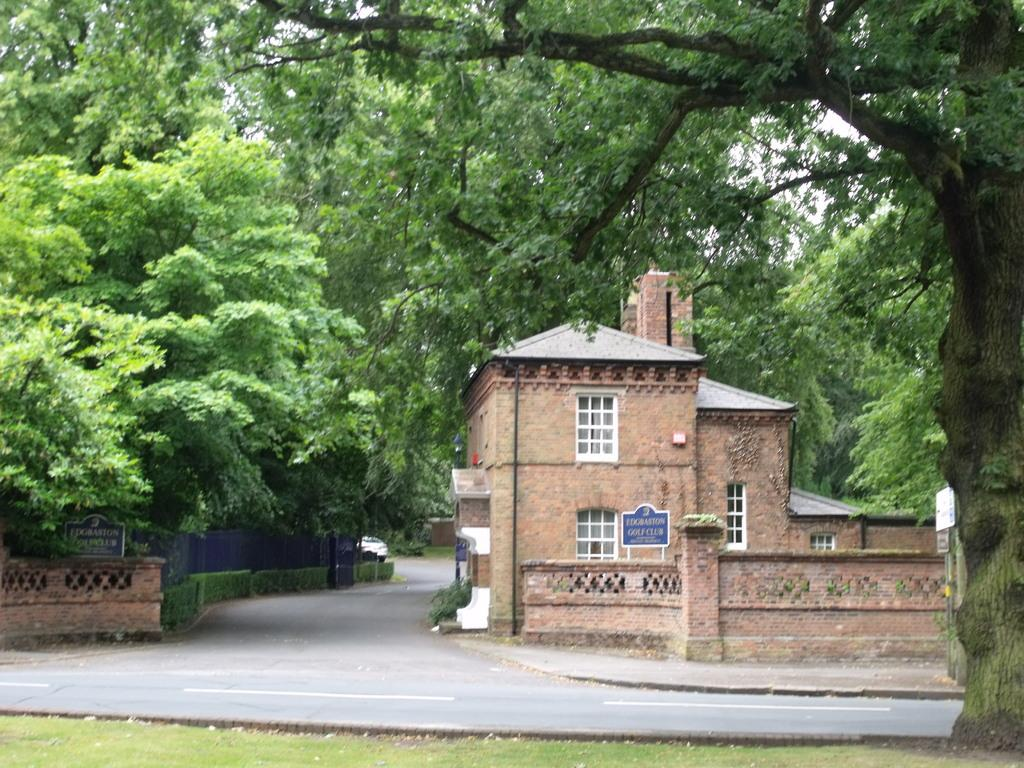What type of structure is visible in the image? There is a house in the image. What is attached to the house? There is a board attached to the house. What type of natural elements can be seen around the house? There are trees and plants around the house. What type of barrier surrounds the house? There is fencing around the house. What type of rice is being cooked in the image? There is no rice present in the image. What type of writing instrument is being used in the image? There is no quill or any writing instrument present in the image. 